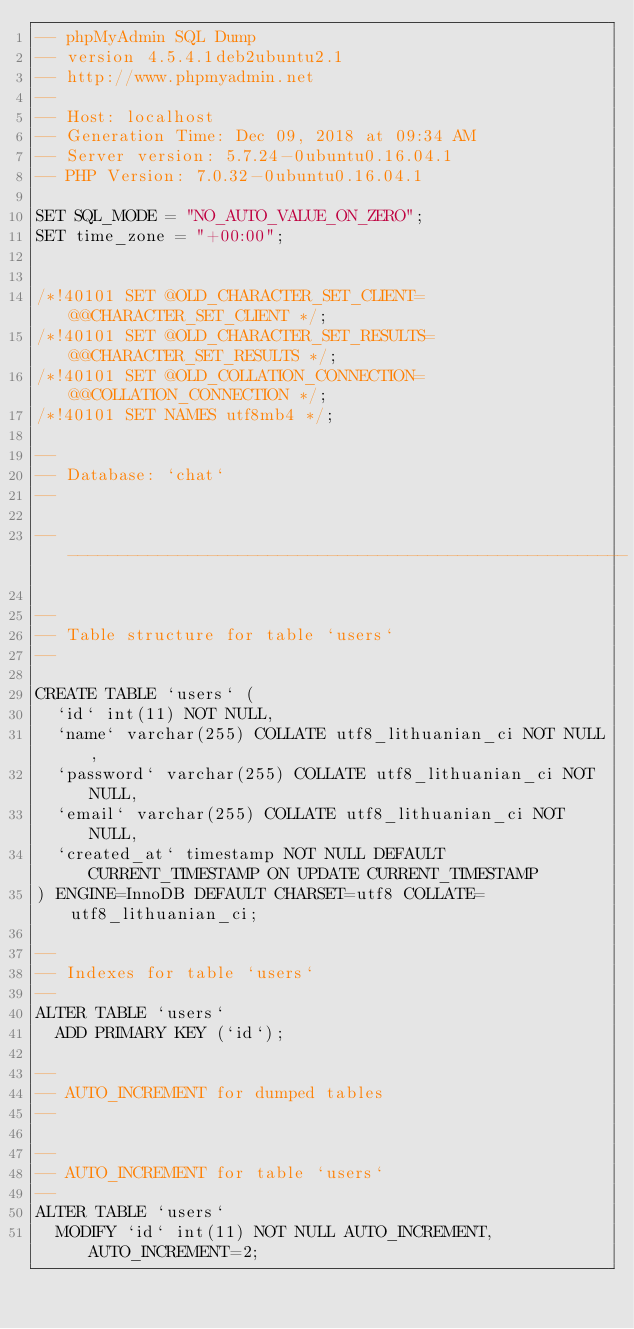Convert code to text. <code><loc_0><loc_0><loc_500><loc_500><_SQL_>-- phpMyAdmin SQL Dump
-- version 4.5.4.1deb2ubuntu2.1
-- http://www.phpmyadmin.net
--
-- Host: localhost
-- Generation Time: Dec 09, 2018 at 09:34 AM
-- Server version: 5.7.24-0ubuntu0.16.04.1
-- PHP Version: 7.0.32-0ubuntu0.16.04.1

SET SQL_MODE = "NO_AUTO_VALUE_ON_ZERO";
SET time_zone = "+00:00";


/*!40101 SET @OLD_CHARACTER_SET_CLIENT=@@CHARACTER_SET_CLIENT */;
/*!40101 SET @OLD_CHARACTER_SET_RESULTS=@@CHARACTER_SET_RESULTS */;
/*!40101 SET @OLD_COLLATION_CONNECTION=@@COLLATION_CONNECTION */;
/*!40101 SET NAMES utf8mb4 */;

--
-- Database: `chat`
--

-- --------------------------------------------------------

--
-- Table structure for table `users`
--

CREATE TABLE `users` (
  `id` int(11) NOT NULL,
  `name` varchar(255) COLLATE utf8_lithuanian_ci NOT NULL,
  `password` varchar(255) COLLATE utf8_lithuanian_ci NOT NULL,
  `email` varchar(255) COLLATE utf8_lithuanian_ci NOT NULL,
  `created_at` timestamp NOT NULL DEFAULT CURRENT_TIMESTAMP ON UPDATE CURRENT_TIMESTAMP
) ENGINE=InnoDB DEFAULT CHARSET=utf8 COLLATE=utf8_lithuanian_ci;

--
-- Indexes for table `users`
--
ALTER TABLE `users`
  ADD PRIMARY KEY (`id`);

--
-- AUTO_INCREMENT for dumped tables
--

--
-- AUTO_INCREMENT for table `users`
--
ALTER TABLE `users`
  MODIFY `id` int(11) NOT NULL AUTO_INCREMENT, AUTO_INCREMENT=2;</code> 